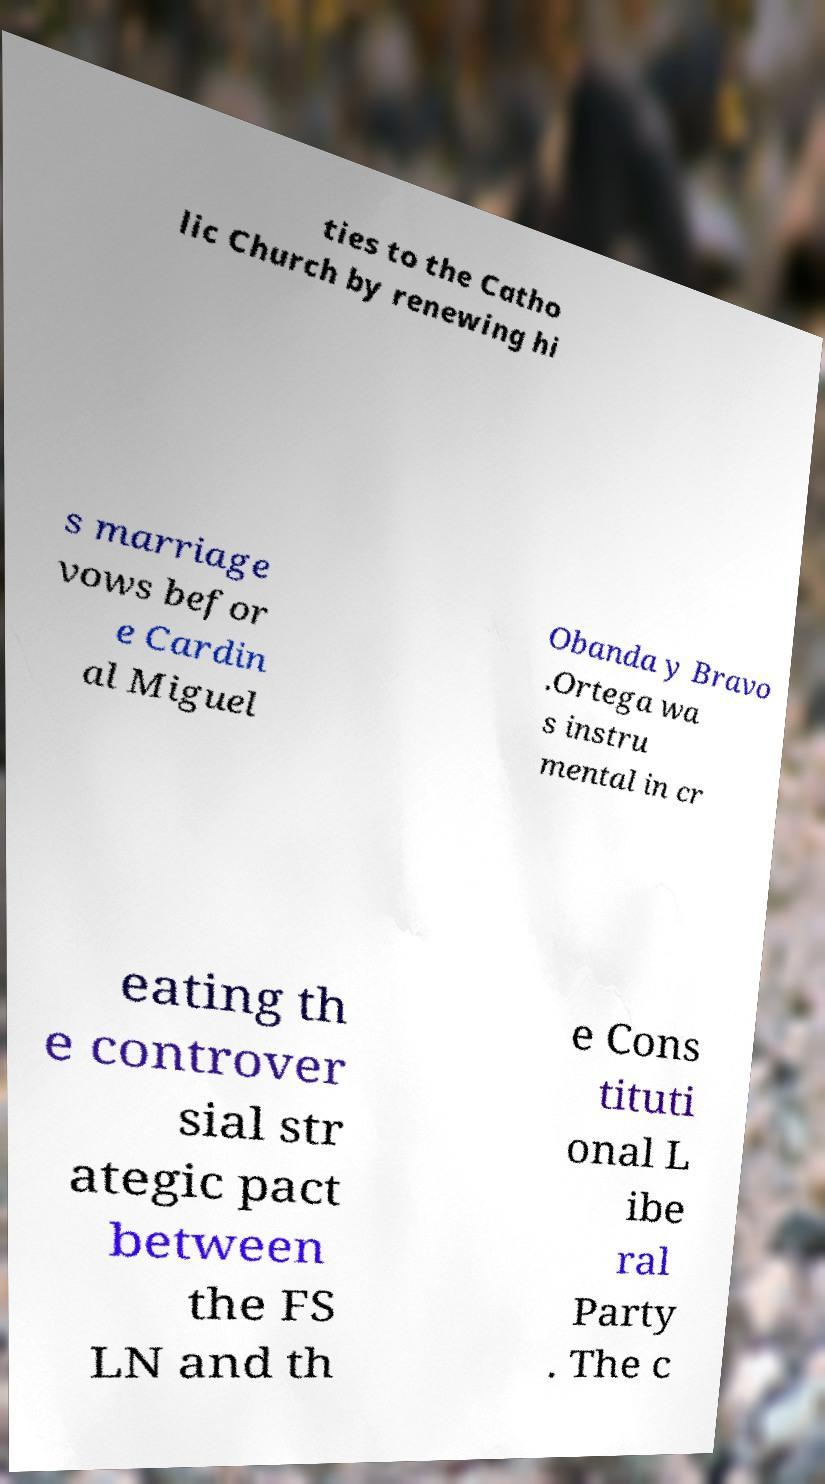Can you read and provide the text displayed in the image?This photo seems to have some interesting text. Can you extract and type it out for me? ties to the Catho lic Church by renewing hi s marriage vows befor e Cardin al Miguel Obanda y Bravo .Ortega wa s instru mental in cr eating th e controver sial str ategic pact between the FS LN and th e Cons tituti onal L ibe ral Party . The c 